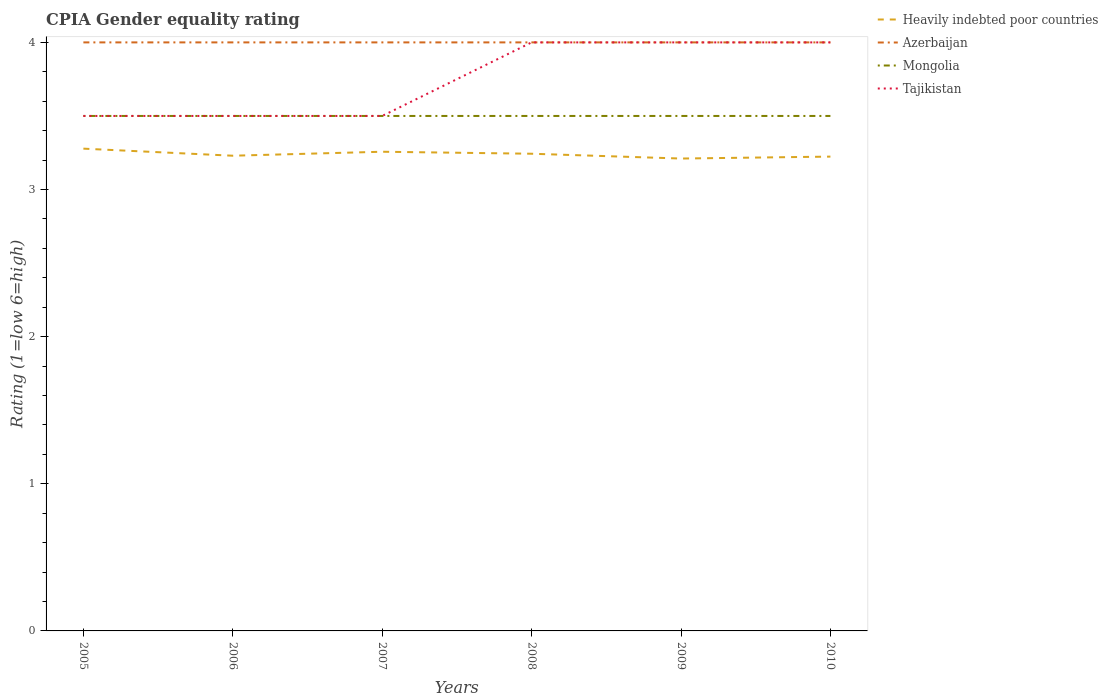Across all years, what is the maximum CPIA rating in Tajikistan?
Offer a very short reply. 3.5. What is the difference between the highest and the second highest CPIA rating in Mongolia?
Your answer should be very brief. 0. How many lines are there?
Keep it short and to the point. 4. What is the difference between two consecutive major ticks on the Y-axis?
Offer a terse response. 1. Are the values on the major ticks of Y-axis written in scientific E-notation?
Provide a short and direct response. No. Does the graph contain any zero values?
Provide a succinct answer. No. Where does the legend appear in the graph?
Give a very brief answer. Top right. What is the title of the graph?
Make the answer very short. CPIA Gender equality rating. What is the Rating (1=low 6=high) of Heavily indebted poor countries in 2005?
Your answer should be compact. 3.28. What is the Rating (1=low 6=high) in Azerbaijan in 2005?
Offer a very short reply. 4. What is the Rating (1=low 6=high) in Mongolia in 2005?
Your answer should be compact. 3.5. What is the Rating (1=low 6=high) of Heavily indebted poor countries in 2006?
Your answer should be very brief. 3.23. What is the Rating (1=low 6=high) of Mongolia in 2006?
Provide a succinct answer. 3.5. What is the Rating (1=low 6=high) in Tajikistan in 2006?
Provide a short and direct response. 3.5. What is the Rating (1=low 6=high) of Heavily indebted poor countries in 2007?
Make the answer very short. 3.26. What is the Rating (1=low 6=high) of Mongolia in 2007?
Make the answer very short. 3.5. What is the Rating (1=low 6=high) in Tajikistan in 2007?
Ensure brevity in your answer.  3.5. What is the Rating (1=low 6=high) in Heavily indebted poor countries in 2008?
Offer a very short reply. 3.24. What is the Rating (1=low 6=high) in Tajikistan in 2008?
Keep it short and to the point. 4. What is the Rating (1=low 6=high) of Heavily indebted poor countries in 2009?
Your answer should be very brief. 3.21. What is the Rating (1=low 6=high) in Azerbaijan in 2009?
Keep it short and to the point. 4. What is the Rating (1=low 6=high) of Tajikistan in 2009?
Your answer should be very brief. 4. What is the Rating (1=low 6=high) of Heavily indebted poor countries in 2010?
Provide a succinct answer. 3.22. Across all years, what is the maximum Rating (1=low 6=high) of Heavily indebted poor countries?
Make the answer very short. 3.28. Across all years, what is the maximum Rating (1=low 6=high) in Mongolia?
Make the answer very short. 3.5. Across all years, what is the minimum Rating (1=low 6=high) of Heavily indebted poor countries?
Make the answer very short. 3.21. Across all years, what is the minimum Rating (1=low 6=high) in Azerbaijan?
Make the answer very short. 4. Across all years, what is the minimum Rating (1=low 6=high) of Mongolia?
Your answer should be compact. 3.5. What is the total Rating (1=low 6=high) in Heavily indebted poor countries in the graph?
Your response must be concise. 19.44. What is the total Rating (1=low 6=high) in Tajikistan in the graph?
Provide a short and direct response. 22.5. What is the difference between the Rating (1=low 6=high) of Heavily indebted poor countries in 2005 and that in 2006?
Offer a very short reply. 0.05. What is the difference between the Rating (1=low 6=high) in Heavily indebted poor countries in 2005 and that in 2007?
Your answer should be very brief. 0.02. What is the difference between the Rating (1=low 6=high) in Azerbaijan in 2005 and that in 2007?
Your answer should be very brief. 0. What is the difference between the Rating (1=low 6=high) in Tajikistan in 2005 and that in 2007?
Keep it short and to the point. 0. What is the difference between the Rating (1=low 6=high) of Heavily indebted poor countries in 2005 and that in 2008?
Your response must be concise. 0.03. What is the difference between the Rating (1=low 6=high) of Azerbaijan in 2005 and that in 2008?
Your response must be concise. 0. What is the difference between the Rating (1=low 6=high) of Heavily indebted poor countries in 2005 and that in 2009?
Your answer should be very brief. 0.07. What is the difference between the Rating (1=low 6=high) of Heavily indebted poor countries in 2005 and that in 2010?
Your answer should be very brief. 0.05. What is the difference between the Rating (1=low 6=high) of Mongolia in 2005 and that in 2010?
Provide a succinct answer. 0. What is the difference between the Rating (1=low 6=high) of Heavily indebted poor countries in 2006 and that in 2007?
Give a very brief answer. -0.03. What is the difference between the Rating (1=low 6=high) in Azerbaijan in 2006 and that in 2007?
Provide a succinct answer. 0. What is the difference between the Rating (1=low 6=high) of Heavily indebted poor countries in 2006 and that in 2008?
Provide a succinct answer. -0.01. What is the difference between the Rating (1=low 6=high) in Mongolia in 2006 and that in 2008?
Offer a terse response. 0. What is the difference between the Rating (1=low 6=high) of Tajikistan in 2006 and that in 2008?
Your answer should be compact. -0.5. What is the difference between the Rating (1=low 6=high) of Heavily indebted poor countries in 2006 and that in 2009?
Your answer should be very brief. 0.02. What is the difference between the Rating (1=low 6=high) of Mongolia in 2006 and that in 2009?
Your answer should be compact. 0. What is the difference between the Rating (1=low 6=high) in Heavily indebted poor countries in 2006 and that in 2010?
Offer a terse response. 0.01. What is the difference between the Rating (1=low 6=high) in Azerbaijan in 2006 and that in 2010?
Provide a short and direct response. 0. What is the difference between the Rating (1=low 6=high) in Heavily indebted poor countries in 2007 and that in 2008?
Give a very brief answer. 0.01. What is the difference between the Rating (1=low 6=high) of Tajikistan in 2007 and that in 2008?
Your answer should be very brief. -0.5. What is the difference between the Rating (1=low 6=high) of Heavily indebted poor countries in 2007 and that in 2009?
Offer a terse response. 0.05. What is the difference between the Rating (1=low 6=high) in Mongolia in 2007 and that in 2009?
Ensure brevity in your answer.  0. What is the difference between the Rating (1=low 6=high) in Tajikistan in 2007 and that in 2009?
Provide a short and direct response. -0.5. What is the difference between the Rating (1=low 6=high) of Heavily indebted poor countries in 2007 and that in 2010?
Your answer should be compact. 0.03. What is the difference between the Rating (1=low 6=high) in Tajikistan in 2007 and that in 2010?
Provide a succinct answer. -0.5. What is the difference between the Rating (1=low 6=high) of Heavily indebted poor countries in 2008 and that in 2009?
Keep it short and to the point. 0.03. What is the difference between the Rating (1=low 6=high) of Azerbaijan in 2008 and that in 2009?
Provide a succinct answer. 0. What is the difference between the Rating (1=low 6=high) of Heavily indebted poor countries in 2008 and that in 2010?
Your answer should be compact. 0.02. What is the difference between the Rating (1=low 6=high) in Azerbaijan in 2008 and that in 2010?
Ensure brevity in your answer.  0. What is the difference between the Rating (1=low 6=high) in Mongolia in 2008 and that in 2010?
Keep it short and to the point. 0. What is the difference between the Rating (1=low 6=high) of Tajikistan in 2008 and that in 2010?
Keep it short and to the point. 0. What is the difference between the Rating (1=low 6=high) of Heavily indebted poor countries in 2009 and that in 2010?
Your answer should be very brief. -0.01. What is the difference between the Rating (1=low 6=high) of Azerbaijan in 2009 and that in 2010?
Offer a terse response. 0. What is the difference between the Rating (1=low 6=high) in Heavily indebted poor countries in 2005 and the Rating (1=low 6=high) in Azerbaijan in 2006?
Provide a succinct answer. -0.72. What is the difference between the Rating (1=low 6=high) in Heavily indebted poor countries in 2005 and the Rating (1=low 6=high) in Mongolia in 2006?
Your answer should be very brief. -0.22. What is the difference between the Rating (1=low 6=high) in Heavily indebted poor countries in 2005 and the Rating (1=low 6=high) in Tajikistan in 2006?
Make the answer very short. -0.22. What is the difference between the Rating (1=low 6=high) of Azerbaijan in 2005 and the Rating (1=low 6=high) of Tajikistan in 2006?
Make the answer very short. 0.5. What is the difference between the Rating (1=low 6=high) of Mongolia in 2005 and the Rating (1=low 6=high) of Tajikistan in 2006?
Give a very brief answer. 0. What is the difference between the Rating (1=low 6=high) of Heavily indebted poor countries in 2005 and the Rating (1=low 6=high) of Azerbaijan in 2007?
Offer a very short reply. -0.72. What is the difference between the Rating (1=low 6=high) in Heavily indebted poor countries in 2005 and the Rating (1=low 6=high) in Mongolia in 2007?
Make the answer very short. -0.22. What is the difference between the Rating (1=low 6=high) in Heavily indebted poor countries in 2005 and the Rating (1=low 6=high) in Tajikistan in 2007?
Your answer should be compact. -0.22. What is the difference between the Rating (1=low 6=high) in Azerbaijan in 2005 and the Rating (1=low 6=high) in Mongolia in 2007?
Your answer should be very brief. 0.5. What is the difference between the Rating (1=low 6=high) in Heavily indebted poor countries in 2005 and the Rating (1=low 6=high) in Azerbaijan in 2008?
Keep it short and to the point. -0.72. What is the difference between the Rating (1=low 6=high) of Heavily indebted poor countries in 2005 and the Rating (1=low 6=high) of Mongolia in 2008?
Offer a terse response. -0.22. What is the difference between the Rating (1=low 6=high) in Heavily indebted poor countries in 2005 and the Rating (1=low 6=high) in Tajikistan in 2008?
Your answer should be very brief. -0.72. What is the difference between the Rating (1=low 6=high) in Azerbaijan in 2005 and the Rating (1=low 6=high) in Mongolia in 2008?
Your response must be concise. 0.5. What is the difference between the Rating (1=low 6=high) in Mongolia in 2005 and the Rating (1=low 6=high) in Tajikistan in 2008?
Your answer should be compact. -0.5. What is the difference between the Rating (1=low 6=high) of Heavily indebted poor countries in 2005 and the Rating (1=low 6=high) of Azerbaijan in 2009?
Your response must be concise. -0.72. What is the difference between the Rating (1=low 6=high) of Heavily indebted poor countries in 2005 and the Rating (1=low 6=high) of Mongolia in 2009?
Offer a very short reply. -0.22. What is the difference between the Rating (1=low 6=high) in Heavily indebted poor countries in 2005 and the Rating (1=low 6=high) in Tajikistan in 2009?
Offer a terse response. -0.72. What is the difference between the Rating (1=low 6=high) of Azerbaijan in 2005 and the Rating (1=low 6=high) of Mongolia in 2009?
Keep it short and to the point. 0.5. What is the difference between the Rating (1=low 6=high) of Mongolia in 2005 and the Rating (1=low 6=high) of Tajikistan in 2009?
Ensure brevity in your answer.  -0.5. What is the difference between the Rating (1=low 6=high) of Heavily indebted poor countries in 2005 and the Rating (1=low 6=high) of Azerbaijan in 2010?
Your response must be concise. -0.72. What is the difference between the Rating (1=low 6=high) of Heavily indebted poor countries in 2005 and the Rating (1=low 6=high) of Mongolia in 2010?
Make the answer very short. -0.22. What is the difference between the Rating (1=low 6=high) of Heavily indebted poor countries in 2005 and the Rating (1=low 6=high) of Tajikistan in 2010?
Offer a terse response. -0.72. What is the difference between the Rating (1=low 6=high) of Mongolia in 2005 and the Rating (1=low 6=high) of Tajikistan in 2010?
Keep it short and to the point. -0.5. What is the difference between the Rating (1=low 6=high) in Heavily indebted poor countries in 2006 and the Rating (1=low 6=high) in Azerbaijan in 2007?
Make the answer very short. -0.77. What is the difference between the Rating (1=low 6=high) of Heavily indebted poor countries in 2006 and the Rating (1=low 6=high) of Mongolia in 2007?
Your answer should be very brief. -0.27. What is the difference between the Rating (1=low 6=high) of Heavily indebted poor countries in 2006 and the Rating (1=low 6=high) of Tajikistan in 2007?
Provide a short and direct response. -0.27. What is the difference between the Rating (1=low 6=high) in Azerbaijan in 2006 and the Rating (1=low 6=high) in Mongolia in 2007?
Offer a terse response. 0.5. What is the difference between the Rating (1=low 6=high) of Azerbaijan in 2006 and the Rating (1=low 6=high) of Tajikistan in 2007?
Provide a succinct answer. 0.5. What is the difference between the Rating (1=low 6=high) of Mongolia in 2006 and the Rating (1=low 6=high) of Tajikistan in 2007?
Your answer should be compact. 0. What is the difference between the Rating (1=low 6=high) of Heavily indebted poor countries in 2006 and the Rating (1=low 6=high) of Azerbaijan in 2008?
Your answer should be compact. -0.77. What is the difference between the Rating (1=low 6=high) of Heavily indebted poor countries in 2006 and the Rating (1=low 6=high) of Mongolia in 2008?
Provide a succinct answer. -0.27. What is the difference between the Rating (1=low 6=high) of Heavily indebted poor countries in 2006 and the Rating (1=low 6=high) of Tajikistan in 2008?
Provide a short and direct response. -0.77. What is the difference between the Rating (1=low 6=high) in Azerbaijan in 2006 and the Rating (1=low 6=high) in Mongolia in 2008?
Offer a terse response. 0.5. What is the difference between the Rating (1=low 6=high) in Mongolia in 2006 and the Rating (1=low 6=high) in Tajikistan in 2008?
Make the answer very short. -0.5. What is the difference between the Rating (1=low 6=high) in Heavily indebted poor countries in 2006 and the Rating (1=low 6=high) in Azerbaijan in 2009?
Keep it short and to the point. -0.77. What is the difference between the Rating (1=low 6=high) of Heavily indebted poor countries in 2006 and the Rating (1=low 6=high) of Mongolia in 2009?
Give a very brief answer. -0.27. What is the difference between the Rating (1=low 6=high) of Heavily indebted poor countries in 2006 and the Rating (1=low 6=high) of Tajikistan in 2009?
Offer a very short reply. -0.77. What is the difference between the Rating (1=low 6=high) of Azerbaijan in 2006 and the Rating (1=low 6=high) of Mongolia in 2009?
Ensure brevity in your answer.  0.5. What is the difference between the Rating (1=low 6=high) in Azerbaijan in 2006 and the Rating (1=low 6=high) in Tajikistan in 2009?
Make the answer very short. 0. What is the difference between the Rating (1=low 6=high) of Heavily indebted poor countries in 2006 and the Rating (1=low 6=high) of Azerbaijan in 2010?
Your answer should be very brief. -0.77. What is the difference between the Rating (1=low 6=high) of Heavily indebted poor countries in 2006 and the Rating (1=low 6=high) of Mongolia in 2010?
Your answer should be very brief. -0.27. What is the difference between the Rating (1=low 6=high) in Heavily indebted poor countries in 2006 and the Rating (1=low 6=high) in Tajikistan in 2010?
Provide a succinct answer. -0.77. What is the difference between the Rating (1=low 6=high) in Heavily indebted poor countries in 2007 and the Rating (1=low 6=high) in Azerbaijan in 2008?
Provide a short and direct response. -0.74. What is the difference between the Rating (1=low 6=high) of Heavily indebted poor countries in 2007 and the Rating (1=low 6=high) of Mongolia in 2008?
Provide a short and direct response. -0.24. What is the difference between the Rating (1=low 6=high) of Heavily indebted poor countries in 2007 and the Rating (1=low 6=high) of Tajikistan in 2008?
Provide a short and direct response. -0.74. What is the difference between the Rating (1=low 6=high) in Mongolia in 2007 and the Rating (1=low 6=high) in Tajikistan in 2008?
Your answer should be compact. -0.5. What is the difference between the Rating (1=low 6=high) in Heavily indebted poor countries in 2007 and the Rating (1=low 6=high) in Azerbaijan in 2009?
Offer a terse response. -0.74. What is the difference between the Rating (1=low 6=high) in Heavily indebted poor countries in 2007 and the Rating (1=low 6=high) in Mongolia in 2009?
Provide a short and direct response. -0.24. What is the difference between the Rating (1=low 6=high) in Heavily indebted poor countries in 2007 and the Rating (1=low 6=high) in Tajikistan in 2009?
Keep it short and to the point. -0.74. What is the difference between the Rating (1=low 6=high) of Azerbaijan in 2007 and the Rating (1=low 6=high) of Tajikistan in 2009?
Give a very brief answer. 0. What is the difference between the Rating (1=low 6=high) in Mongolia in 2007 and the Rating (1=low 6=high) in Tajikistan in 2009?
Provide a succinct answer. -0.5. What is the difference between the Rating (1=low 6=high) of Heavily indebted poor countries in 2007 and the Rating (1=low 6=high) of Azerbaijan in 2010?
Offer a terse response. -0.74. What is the difference between the Rating (1=low 6=high) in Heavily indebted poor countries in 2007 and the Rating (1=low 6=high) in Mongolia in 2010?
Provide a succinct answer. -0.24. What is the difference between the Rating (1=low 6=high) of Heavily indebted poor countries in 2007 and the Rating (1=low 6=high) of Tajikistan in 2010?
Your answer should be compact. -0.74. What is the difference between the Rating (1=low 6=high) of Azerbaijan in 2007 and the Rating (1=low 6=high) of Mongolia in 2010?
Ensure brevity in your answer.  0.5. What is the difference between the Rating (1=low 6=high) in Azerbaijan in 2007 and the Rating (1=low 6=high) in Tajikistan in 2010?
Ensure brevity in your answer.  0. What is the difference between the Rating (1=low 6=high) in Heavily indebted poor countries in 2008 and the Rating (1=low 6=high) in Azerbaijan in 2009?
Provide a succinct answer. -0.76. What is the difference between the Rating (1=low 6=high) in Heavily indebted poor countries in 2008 and the Rating (1=low 6=high) in Mongolia in 2009?
Keep it short and to the point. -0.26. What is the difference between the Rating (1=low 6=high) of Heavily indebted poor countries in 2008 and the Rating (1=low 6=high) of Tajikistan in 2009?
Your answer should be compact. -0.76. What is the difference between the Rating (1=low 6=high) in Azerbaijan in 2008 and the Rating (1=low 6=high) in Mongolia in 2009?
Give a very brief answer. 0.5. What is the difference between the Rating (1=low 6=high) in Azerbaijan in 2008 and the Rating (1=low 6=high) in Tajikistan in 2009?
Your answer should be very brief. 0. What is the difference between the Rating (1=low 6=high) in Mongolia in 2008 and the Rating (1=low 6=high) in Tajikistan in 2009?
Offer a very short reply. -0.5. What is the difference between the Rating (1=low 6=high) in Heavily indebted poor countries in 2008 and the Rating (1=low 6=high) in Azerbaijan in 2010?
Give a very brief answer. -0.76. What is the difference between the Rating (1=low 6=high) in Heavily indebted poor countries in 2008 and the Rating (1=low 6=high) in Mongolia in 2010?
Ensure brevity in your answer.  -0.26. What is the difference between the Rating (1=low 6=high) of Heavily indebted poor countries in 2008 and the Rating (1=low 6=high) of Tajikistan in 2010?
Give a very brief answer. -0.76. What is the difference between the Rating (1=low 6=high) of Heavily indebted poor countries in 2009 and the Rating (1=low 6=high) of Azerbaijan in 2010?
Offer a terse response. -0.79. What is the difference between the Rating (1=low 6=high) in Heavily indebted poor countries in 2009 and the Rating (1=low 6=high) in Mongolia in 2010?
Your response must be concise. -0.29. What is the difference between the Rating (1=low 6=high) in Heavily indebted poor countries in 2009 and the Rating (1=low 6=high) in Tajikistan in 2010?
Give a very brief answer. -0.79. What is the difference between the Rating (1=low 6=high) of Azerbaijan in 2009 and the Rating (1=low 6=high) of Mongolia in 2010?
Provide a short and direct response. 0.5. What is the difference between the Rating (1=low 6=high) in Azerbaijan in 2009 and the Rating (1=low 6=high) in Tajikistan in 2010?
Offer a terse response. 0. What is the difference between the Rating (1=low 6=high) in Mongolia in 2009 and the Rating (1=low 6=high) in Tajikistan in 2010?
Provide a short and direct response. -0.5. What is the average Rating (1=low 6=high) of Heavily indebted poor countries per year?
Keep it short and to the point. 3.24. What is the average Rating (1=low 6=high) of Mongolia per year?
Give a very brief answer. 3.5. What is the average Rating (1=low 6=high) in Tajikistan per year?
Offer a terse response. 3.75. In the year 2005, what is the difference between the Rating (1=low 6=high) of Heavily indebted poor countries and Rating (1=low 6=high) of Azerbaijan?
Your response must be concise. -0.72. In the year 2005, what is the difference between the Rating (1=low 6=high) of Heavily indebted poor countries and Rating (1=low 6=high) of Mongolia?
Make the answer very short. -0.22. In the year 2005, what is the difference between the Rating (1=low 6=high) of Heavily indebted poor countries and Rating (1=low 6=high) of Tajikistan?
Keep it short and to the point. -0.22. In the year 2005, what is the difference between the Rating (1=low 6=high) of Azerbaijan and Rating (1=low 6=high) of Mongolia?
Offer a terse response. 0.5. In the year 2005, what is the difference between the Rating (1=low 6=high) in Azerbaijan and Rating (1=low 6=high) in Tajikistan?
Your answer should be compact. 0.5. In the year 2006, what is the difference between the Rating (1=low 6=high) in Heavily indebted poor countries and Rating (1=low 6=high) in Azerbaijan?
Give a very brief answer. -0.77. In the year 2006, what is the difference between the Rating (1=low 6=high) in Heavily indebted poor countries and Rating (1=low 6=high) in Mongolia?
Your answer should be compact. -0.27. In the year 2006, what is the difference between the Rating (1=low 6=high) in Heavily indebted poor countries and Rating (1=low 6=high) in Tajikistan?
Your answer should be very brief. -0.27. In the year 2006, what is the difference between the Rating (1=low 6=high) in Azerbaijan and Rating (1=low 6=high) in Mongolia?
Your answer should be very brief. 0.5. In the year 2006, what is the difference between the Rating (1=low 6=high) of Azerbaijan and Rating (1=low 6=high) of Tajikistan?
Offer a terse response. 0.5. In the year 2007, what is the difference between the Rating (1=low 6=high) in Heavily indebted poor countries and Rating (1=low 6=high) in Azerbaijan?
Your answer should be compact. -0.74. In the year 2007, what is the difference between the Rating (1=low 6=high) in Heavily indebted poor countries and Rating (1=low 6=high) in Mongolia?
Provide a succinct answer. -0.24. In the year 2007, what is the difference between the Rating (1=low 6=high) in Heavily indebted poor countries and Rating (1=low 6=high) in Tajikistan?
Give a very brief answer. -0.24. In the year 2007, what is the difference between the Rating (1=low 6=high) in Azerbaijan and Rating (1=low 6=high) in Mongolia?
Your answer should be very brief. 0.5. In the year 2007, what is the difference between the Rating (1=low 6=high) of Mongolia and Rating (1=low 6=high) of Tajikistan?
Offer a very short reply. 0. In the year 2008, what is the difference between the Rating (1=low 6=high) in Heavily indebted poor countries and Rating (1=low 6=high) in Azerbaijan?
Your response must be concise. -0.76. In the year 2008, what is the difference between the Rating (1=low 6=high) of Heavily indebted poor countries and Rating (1=low 6=high) of Mongolia?
Your response must be concise. -0.26. In the year 2008, what is the difference between the Rating (1=low 6=high) in Heavily indebted poor countries and Rating (1=low 6=high) in Tajikistan?
Your answer should be very brief. -0.76. In the year 2008, what is the difference between the Rating (1=low 6=high) of Mongolia and Rating (1=low 6=high) of Tajikistan?
Offer a terse response. -0.5. In the year 2009, what is the difference between the Rating (1=low 6=high) of Heavily indebted poor countries and Rating (1=low 6=high) of Azerbaijan?
Provide a short and direct response. -0.79. In the year 2009, what is the difference between the Rating (1=low 6=high) of Heavily indebted poor countries and Rating (1=low 6=high) of Mongolia?
Provide a short and direct response. -0.29. In the year 2009, what is the difference between the Rating (1=low 6=high) of Heavily indebted poor countries and Rating (1=low 6=high) of Tajikistan?
Offer a very short reply. -0.79. In the year 2009, what is the difference between the Rating (1=low 6=high) in Azerbaijan and Rating (1=low 6=high) in Mongolia?
Your answer should be very brief. 0.5. In the year 2009, what is the difference between the Rating (1=low 6=high) in Azerbaijan and Rating (1=low 6=high) in Tajikistan?
Make the answer very short. 0. In the year 2009, what is the difference between the Rating (1=low 6=high) of Mongolia and Rating (1=low 6=high) of Tajikistan?
Your response must be concise. -0.5. In the year 2010, what is the difference between the Rating (1=low 6=high) in Heavily indebted poor countries and Rating (1=low 6=high) in Azerbaijan?
Offer a very short reply. -0.78. In the year 2010, what is the difference between the Rating (1=low 6=high) of Heavily indebted poor countries and Rating (1=low 6=high) of Mongolia?
Make the answer very short. -0.28. In the year 2010, what is the difference between the Rating (1=low 6=high) of Heavily indebted poor countries and Rating (1=low 6=high) of Tajikistan?
Provide a short and direct response. -0.78. In the year 2010, what is the difference between the Rating (1=low 6=high) of Azerbaijan and Rating (1=low 6=high) of Mongolia?
Keep it short and to the point. 0.5. What is the ratio of the Rating (1=low 6=high) of Heavily indebted poor countries in 2005 to that in 2006?
Offer a very short reply. 1.01. What is the ratio of the Rating (1=low 6=high) in Tajikistan in 2005 to that in 2006?
Make the answer very short. 1. What is the ratio of the Rating (1=low 6=high) in Tajikistan in 2005 to that in 2007?
Keep it short and to the point. 1. What is the ratio of the Rating (1=low 6=high) in Heavily indebted poor countries in 2005 to that in 2008?
Offer a terse response. 1.01. What is the ratio of the Rating (1=low 6=high) in Tajikistan in 2005 to that in 2008?
Offer a terse response. 0.88. What is the ratio of the Rating (1=low 6=high) of Heavily indebted poor countries in 2005 to that in 2009?
Make the answer very short. 1.02. What is the ratio of the Rating (1=low 6=high) of Azerbaijan in 2005 to that in 2009?
Offer a very short reply. 1. What is the ratio of the Rating (1=low 6=high) of Mongolia in 2005 to that in 2009?
Provide a succinct answer. 1. What is the ratio of the Rating (1=low 6=high) in Heavily indebted poor countries in 2005 to that in 2010?
Keep it short and to the point. 1.02. What is the ratio of the Rating (1=low 6=high) of Mongolia in 2005 to that in 2010?
Ensure brevity in your answer.  1. What is the ratio of the Rating (1=low 6=high) of Tajikistan in 2005 to that in 2010?
Your answer should be compact. 0.88. What is the ratio of the Rating (1=low 6=high) in Mongolia in 2006 to that in 2007?
Provide a succinct answer. 1. What is the ratio of the Rating (1=low 6=high) in Heavily indebted poor countries in 2006 to that in 2008?
Provide a short and direct response. 1. What is the ratio of the Rating (1=low 6=high) in Azerbaijan in 2006 to that in 2009?
Give a very brief answer. 1. What is the ratio of the Rating (1=low 6=high) of Heavily indebted poor countries in 2006 to that in 2010?
Keep it short and to the point. 1. What is the ratio of the Rating (1=low 6=high) of Azerbaijan in 2006 to that in 2010?
Offer a very short reply. 1. What is the ratio of the Rating (1=low 6=high) of Azerbaijan in 2007 to that in 2008?
Make the answer very short. 1. What is the ratio of the Rating (1=low 6=high) of Mongolia in 2007 to that in 2008?
Keep it short and to the point. 1. What is the ratio of the Rating (1=low 6=high) of Tajikistan in 2007 to that in 2008?
Your answer should be compact. 0.88. What is the ratio of the Rating (1=low 6=high) of Heavily indebted poor countries in 2007 to that in 2009?
Provide a succinct answer. 1.01. What is the ratio of the Rating (1=low 6=high) of Heavily indebted poor countries in 2007 to that in 2010?
Offer a terse response. 1.01. What is the ratio of the Rating (1=low 6=high) in Tajikistan in 2007 to that in 2010?
Your answer should be compact. 0.88. What is the ratio of the Rating (1=low 6=high) in Heavily indebted poor countries in 2008 to that in 2009?
Offer a very short reply. 1.01. What is the ratio of the Rating (1=low 6=high) of Azerbaijan in 2008 to that in 2009?
Keep it short and to the point. 1. What is the ratio of the Rating (1=low 6=high) in Heavily indebted poor countries in 2008 to that in 2010?
Offer a very short reply. 1.01. What is the ratio of the Rating (1=low 6=high) of Tajikistan in 2008 to that in 2010?
Give a very brief answer. 1. What is the ratio of the Rating (1=low 6=high) of Heavily indebted poor countries in 2009 to that in 2010?
Ensure brevity in your answer.  1. What is the ratio of the Rating (1=low 6=high) of Azerbaijan in 2009 to that in 2010?
Provide a short and direct response. 1. What is the ratio of the Rating (1=low 6=high) of Mongolia in 2009 to that in 2010?
Your answer should be very brief. 1. What is the ratio of the Rating (1=low 6=high) of Tajikistan in 2009 to that in 2010?
Keep it short and to the point. 1. What is the difference between the highest and the second highest Rating (1=low 6=high) in Heavily indebted poor countries?
Your answer should be compact. 0.02. What is the difference between the highest and the second highest Rating (1=low 6=high) in Tajikistan?
Give a very brief answer. 0. What is the difference between the highest and the lowest Rating (1=low 6=high) of Heavily indebted poor countries?
Your response must be concise. 0.07. What is the difference between the highest and the lowest Rating (1=low 6=high) of Mongolia?
Offer a very short reply. 0. What is the difference between the highest and the lowest Rating (1=low 6=high) of Tajikistan?
Provide a succinct answer. 0.5. 